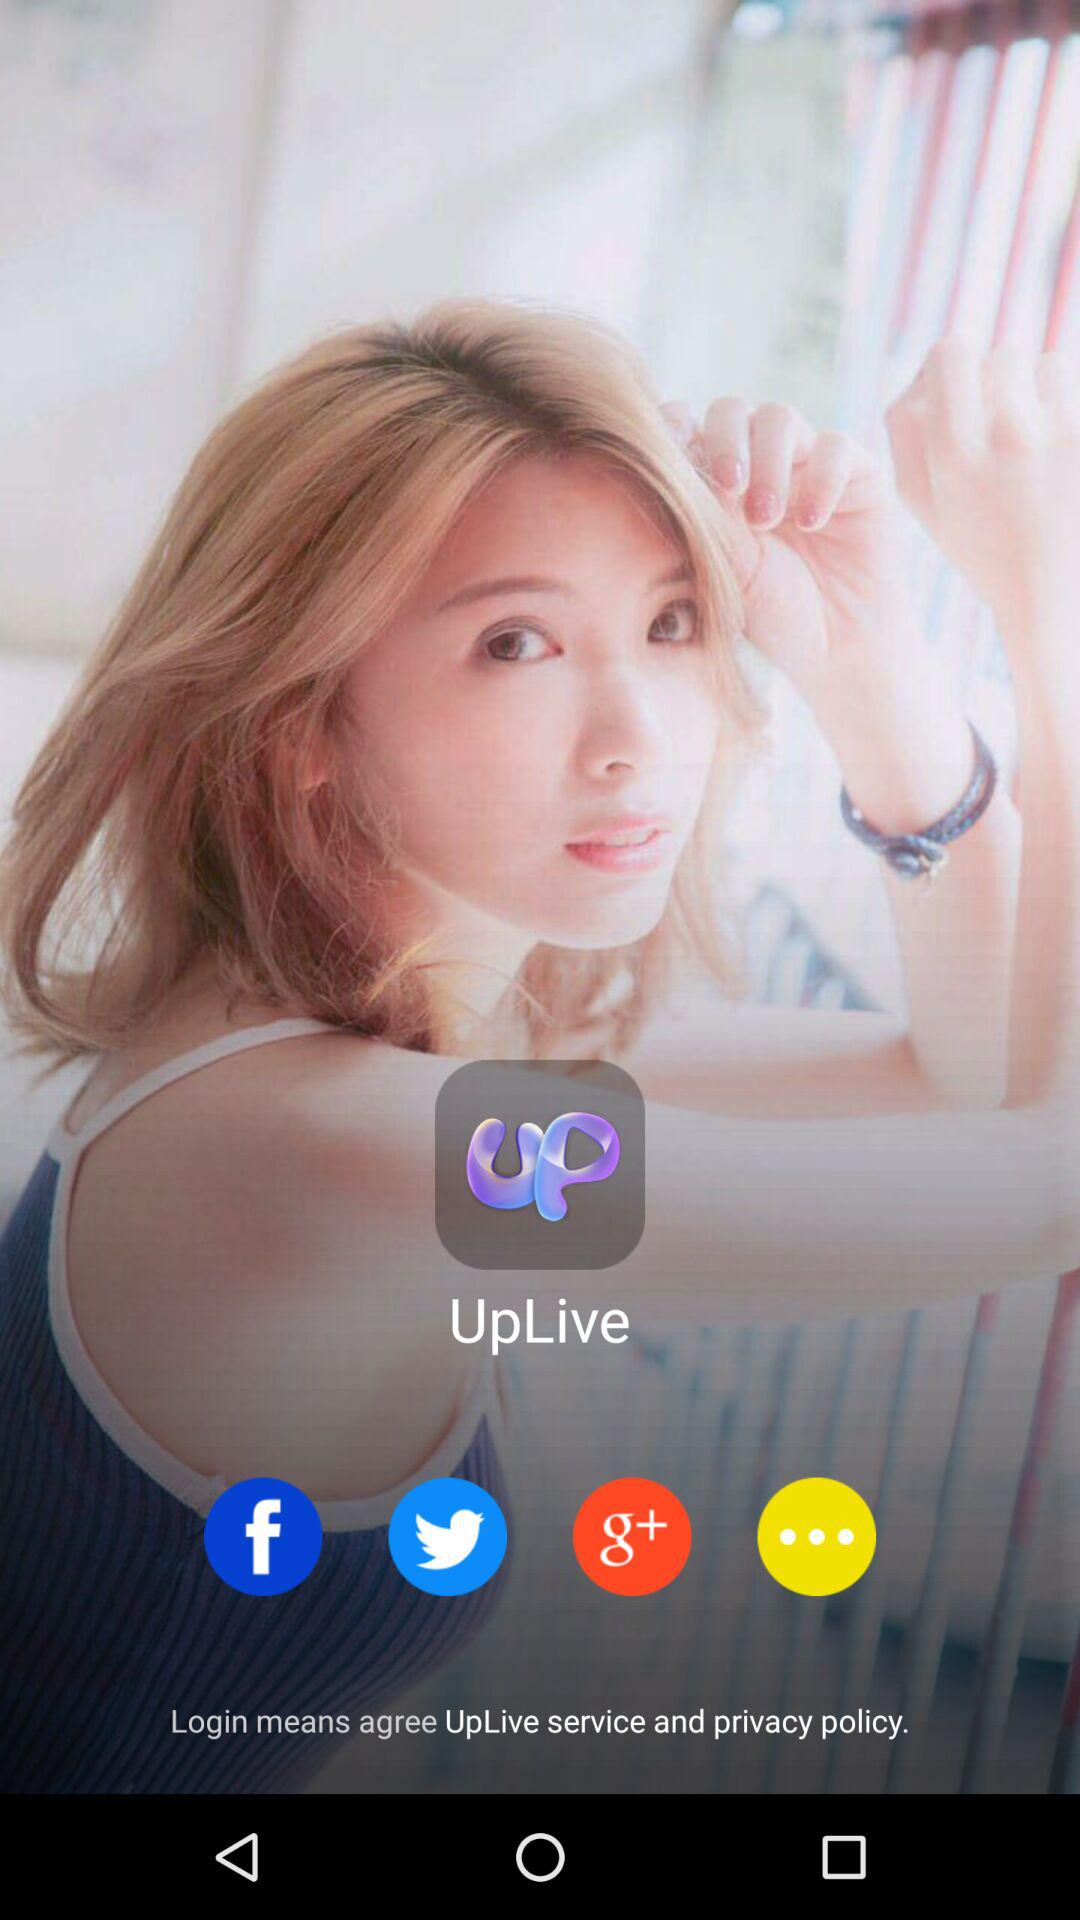What is the app title? The title is "UpLive". 